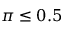<formula> <loc_0><loc_0><loc_500><loc_500>\pi \leq 0 . 5</formula> 